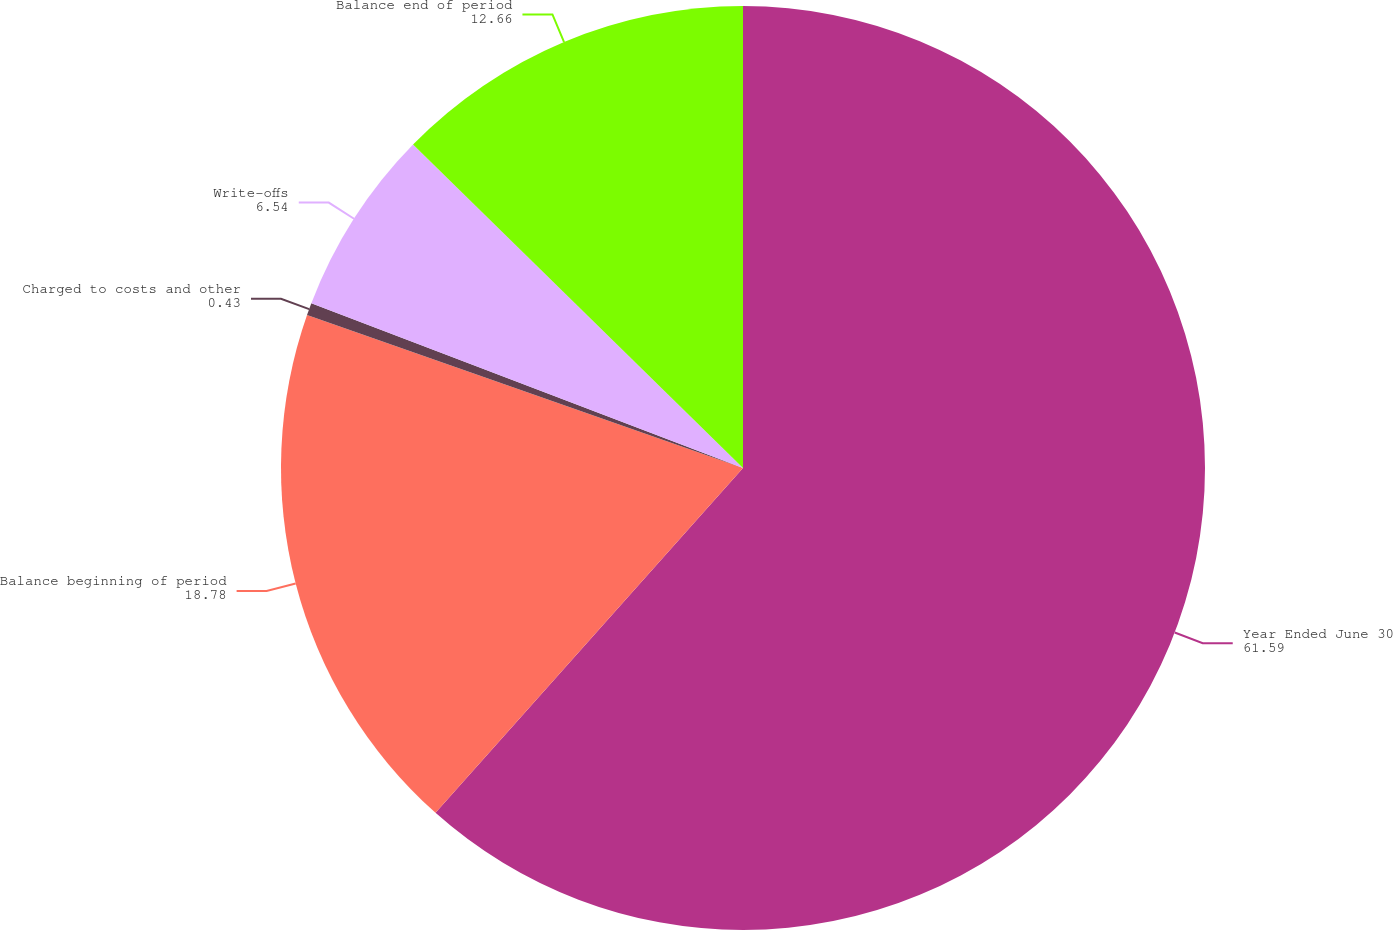Convert chart to OTSL. <chart><loc_0><loc_0><loc_500><loc_500><pie_chart><fcel>Year Ended June 30<fcel>Balance beginning of period<fcel>Charged to costs and other<fcel>Write-offs<fcel>Balance end of period<nl><fcel>61.59%<fcel>18.78%<fcel>0.43%<fcel>6.54%<fcel>12.66%<nl></chart> 